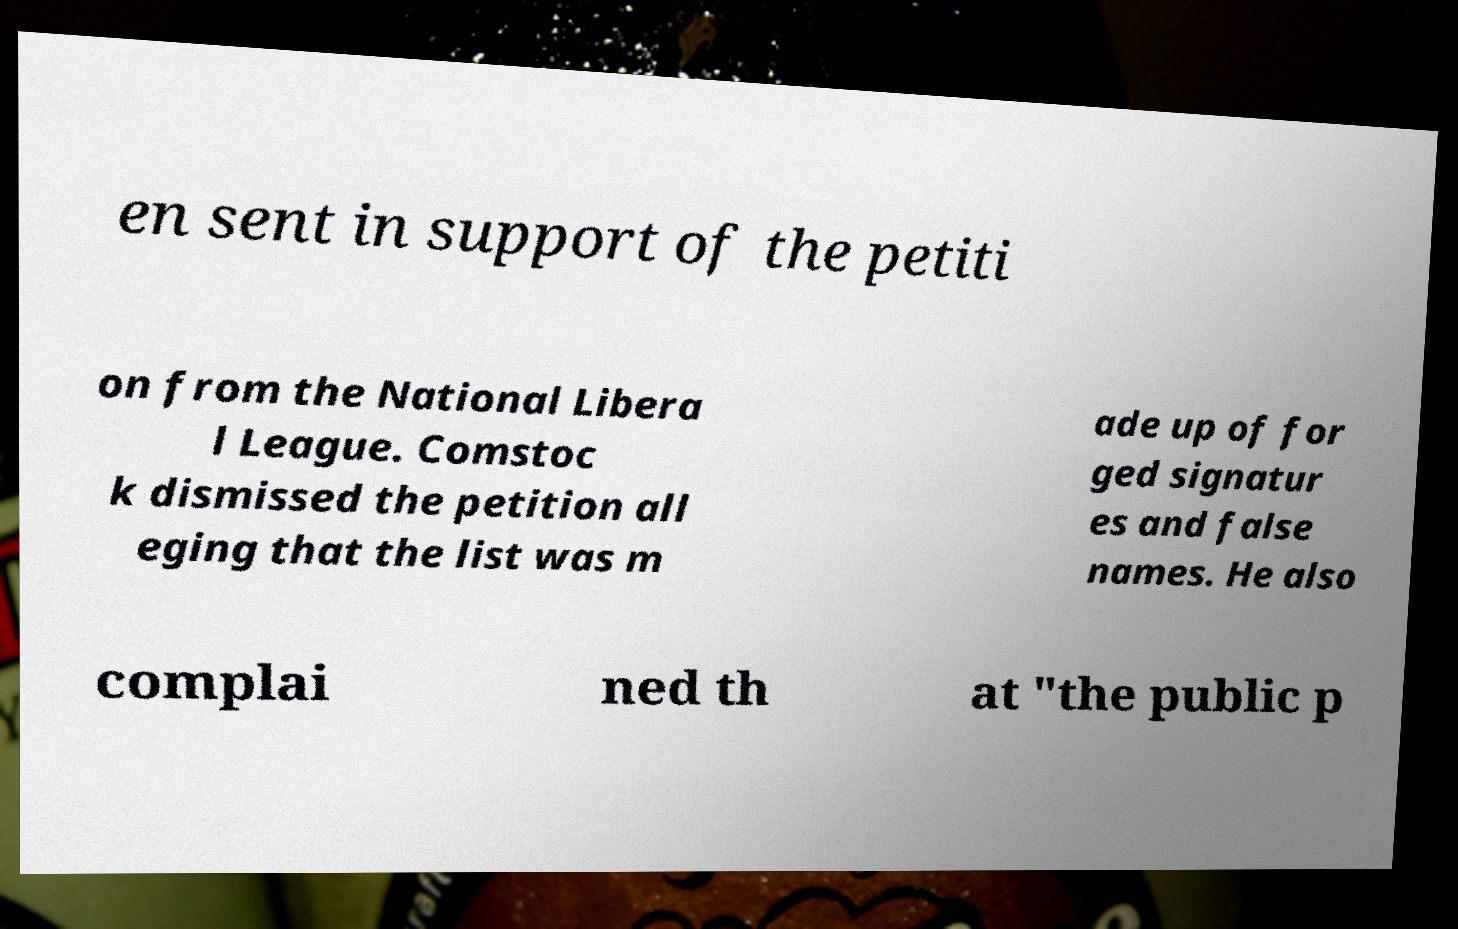Could you assist in decoding the text presented in this image and type it out clearly? en sent in support of the petiti on from the National Libera l League. Comstoc k dismissed the petition all eging that the list was m ade up of for ged signatur es and false names. He also complai ned th at "the public p 